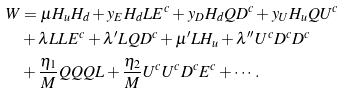Convert formula to latex. <formula><loc_0><loc_0><loc_500><loc_500>W & = \mu H _ { u } H _ { d } + y _ { E } H _ { d } L E ^ { c } + y _ { D } H _ { d } Q D ^ { c } + y _ { U } H _ { u } Q U ^ { c } \\ & + \lambda L L E ^ { c } + \lambda ^ { \prime } L Q D ^ { c } + \mu ^ { \prime } L H _ { u } + \lambda ^ { \prime \prime } U ^ { c } D ^ { c } D ^ { c } \\ & + \frac { \eta _ { 1 } } { M } Q Q Q L + \frac { \eta _ { 2 } } { M } U ^ { c } U ^ { c } D ^ { c } E ^ { c } + \cdots .</formula> 